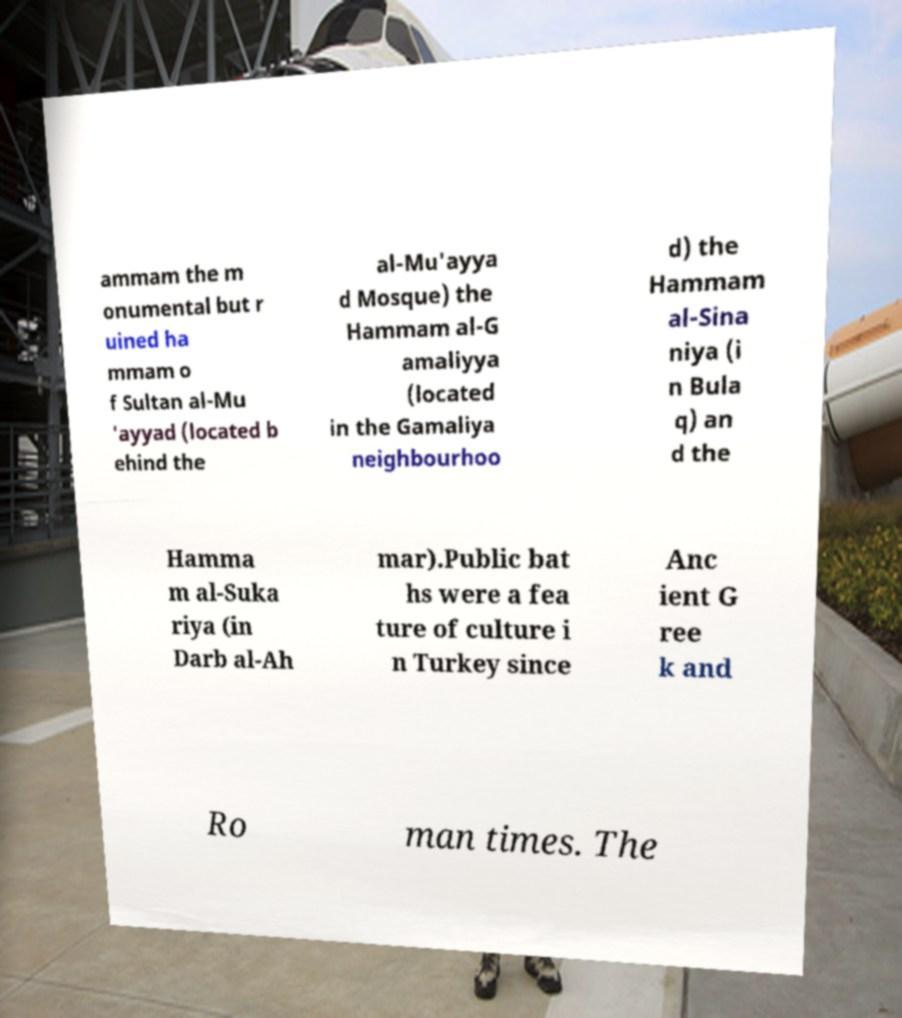There's text embedded in this image that I need extracted. Can you transcribe it verbatim? ammam the m onumental but r uined ha mmam o f Sultan al-Mu 'ayyad (located b ehind the al-Mu'ayya d Mosque) the Hammam al-G amaliyya (located in the Gamaliya neighbourhoo d) the Hammam al-Sina niya (i n Bula q) an d the Hamma m al-Suka riya (in Darb al-Ah mar).Public bat hs were a fea ture of culture i n Turkey since Anc ient G ree k and Ro man times. The 